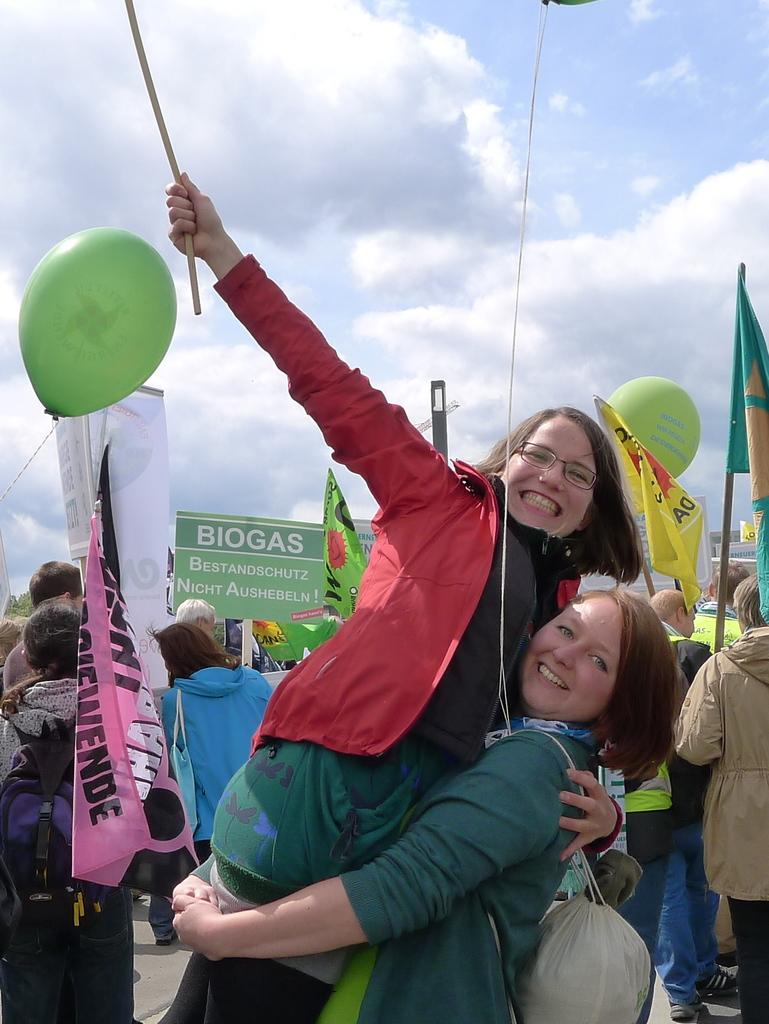How many people are in the group visible in the image? There is a group of people in the image, but the exact number cannot be determined from the provided facts. What can be seen besides the group of people in the image? There are balloons, flags, boards, and other objects visible in the image. What is the condition of the sky in the background of the image? The sky is visible in the background of the image, and clouds are present. What type of credit card is being used by the person in the image? There is no credit card visible in the image. What activity are the people in the group participating in? The provided facts do not give any information about the activity the group of people might be participating in. 